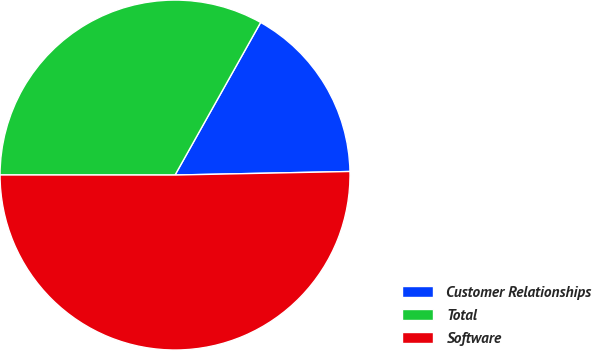Convert chart to OTSL. <chart><loc_0><loc_0><loc_500><loc_500><pie_chart><fcel>Customer Relationships<fcel>Total<fcel>Software<nl><fcel>16.54%<fcel>33.13%<fcel>50.33%<nl></chart> 